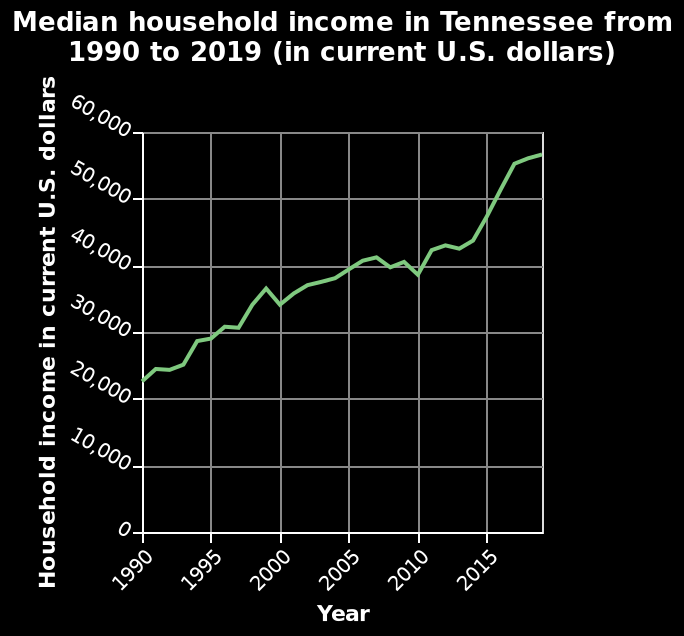<image>
What is being represented on the x-axis of the line chart?  The x-axis represents the years from 1990 to 2015. What is the range of the x-axis on the line graph?  The range of the x-axis is from 1990 to 2015. Over what time period does the line graph depict the median household income in Tennessee? The line graph depicts the median household income in Tennessee from 1990 to 2019. 